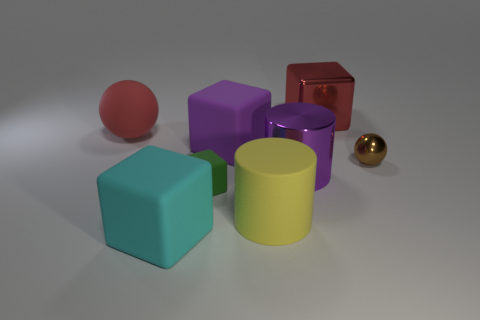There is a ball that is left of the tiny green rubber cube; is it the same color as the big block that is right of the purple block?
Keep it short and to the point. Yes. What is the material of the brown object?
Give a very brief answer. Metal. There is a metallic thing that is the same color as the big rubber ball; what shape is it?
Provide a succinct answer. Cube. There is a red thing that is left of the large red object on the right side of the big red matte object; what number of purple matte things are to the left of it?
Give a very brief answer. 0. The shiny cube that is the same size as the red sphere is what color?
Ensure brevity in your answer.  Red. What number of other things are the same color as the big rubber ball?
Your answer should be compact. 1. Is the number of large cyan things on the right side of the large cyan rubber thing greater than the number of large yellow rubber cylinders?
Ensure brevity in your answer.  No. Is the material of the red cube the same as the small sphere?
Provide a succinct answer. Yes. What number of things are either large purple metallic cylinders that are right of the cyan object or large yellow matte things?
Your answer should be compact. 2. How many other things are the same size as the red matte ball?
Offer a very short reply. 5. 